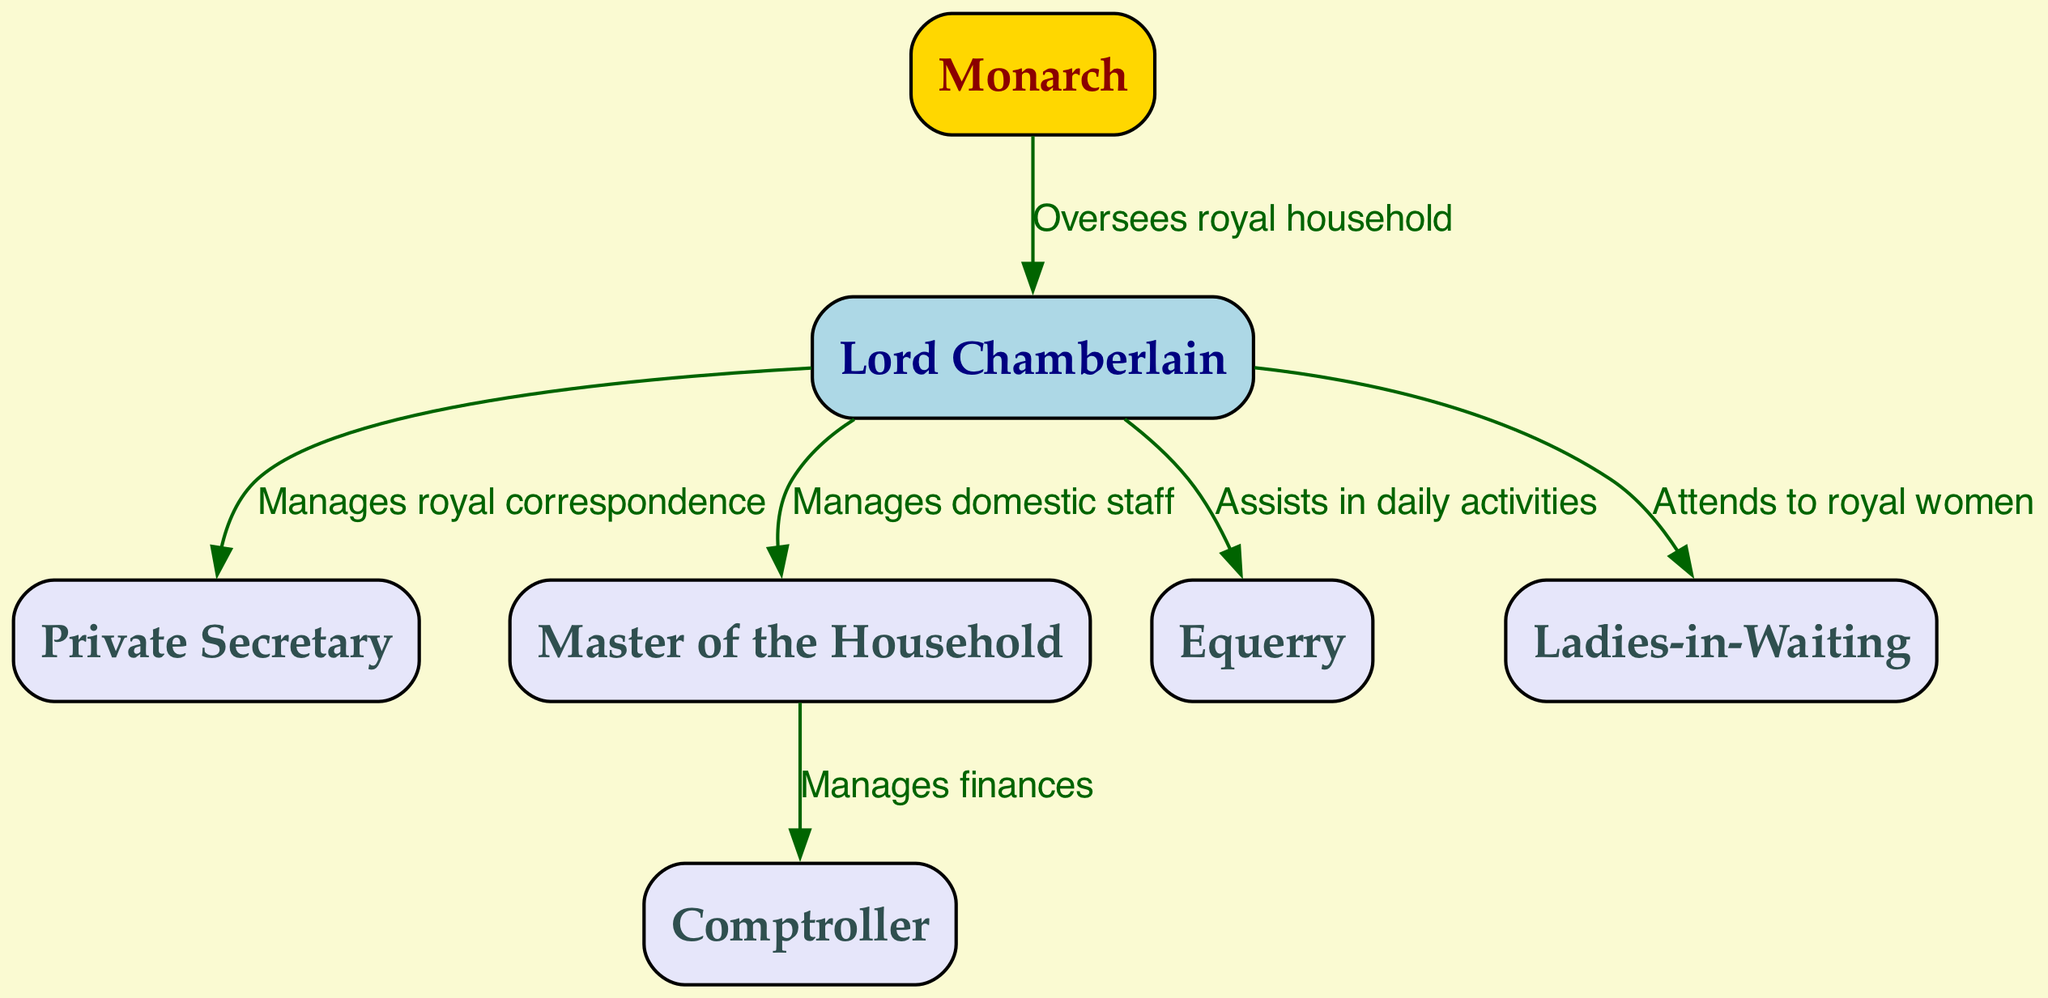What is the highest position in the diagram? The highest position is represented by the "Monarch" node, which does not have any incoming edges from other nodes, indicating it is at the top of the hierarchy.
Answer: Monarch How many nodes are in the diagram? By counting each individual node listed in the diagram, there are a total of 7 nodes.
Answer: 7 Who manages royal correspondence? The "Private Secretary" node is directly connected to the "Lord Chamberlain" node with an edge labeled "Manages royal correspondence," indicating that the Private Secretary handles this responsibility.
Answer: Private Secretary Which role assists the Lord Chamberlain in daily activities? The "Equerry" node has a direct edge coming from the "Lord Chamberlain" with the label "Assists in daily activities," showing that the Equerry fulfills this role.
Answer: Equerry What is the relationship between the Master of Household and the Comptroller? The "Master of Household" node has a directed edge that goes to the "Comptroller" node labeled "Manages finances," indicating that the Master of Household oversees the financial responsibilities within the household.
Answer: Manages finances How many edges are present in the diagram? The diagram has a total of 6 edges, which represent the relationships between the positions in the royal household hierarchy.
Answer: 6 Which node directly connects to the Lord Chamberlain and oversees royal women? The "Ladies-in-Waiting" node is connected to the "Lord Chamberlain" with an edge labeled "Attends to royal women," indicating that this role attends to the needs of the royal women.
Answer: Ladies-in-Waiting What is the primary responsibility of the Lord Chamberlain? The direct edge from the "Monarch" to the "Lord Chamberlain" with the label "Oversees royal household" indicates that the Lord Chamberlain's primary responsibility is overseeing the entire royal household.
Answer: Oversees royal household What role manages domestic staff? The "Master of the Household" is connected to the "Lord Chamberlain" with an edge labeled "Manages domestic staff," meaning this role is specifically responsible for managing domestic staff.
Answer: Manages domestic staff 